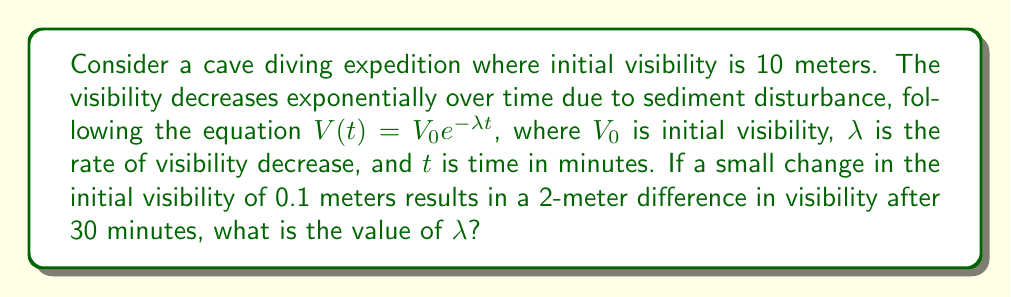Provide a solution to this math problem. Let's approach this step-by-step:

1) We start with the visibility equation:
   $V(t) = V_0e^{-\lambda t}$

2) We have two scenarios:
   Scenario 1: $V_1(30) = 10e^{-30\lambda}$
   Scenario 2: $V_2(30) = 10.1e^{-30\lambda}$

3) The difference between these scenarios is 2 meters:
   $V_2(30) - V_1(30) = 2$

4) Substituting:
   $10.1e^{-30\lambda} - 10e^{-30\lambda} = 2$

5) Factoring out $e^{-30\lambda}$:
   $(10.1 - 10)e^{-30\lambda} = 2$

6) Simplifying:
   $0.1e^{-30\lambda} = 2$

7) Dividing both sides by 0.1:
   $e^{-30\lambda} = 20$

8) Taking the natural log of both sides:
   $-30\lambda = \ln(20)$

9) Solving for $\lambda$:
   $\lambda = -\frac{\ln(20)}{30}$

10) Calculating the final value:
    $\lambda \approx 0.1$
Answer: $\lambda \approx 0.1$ 